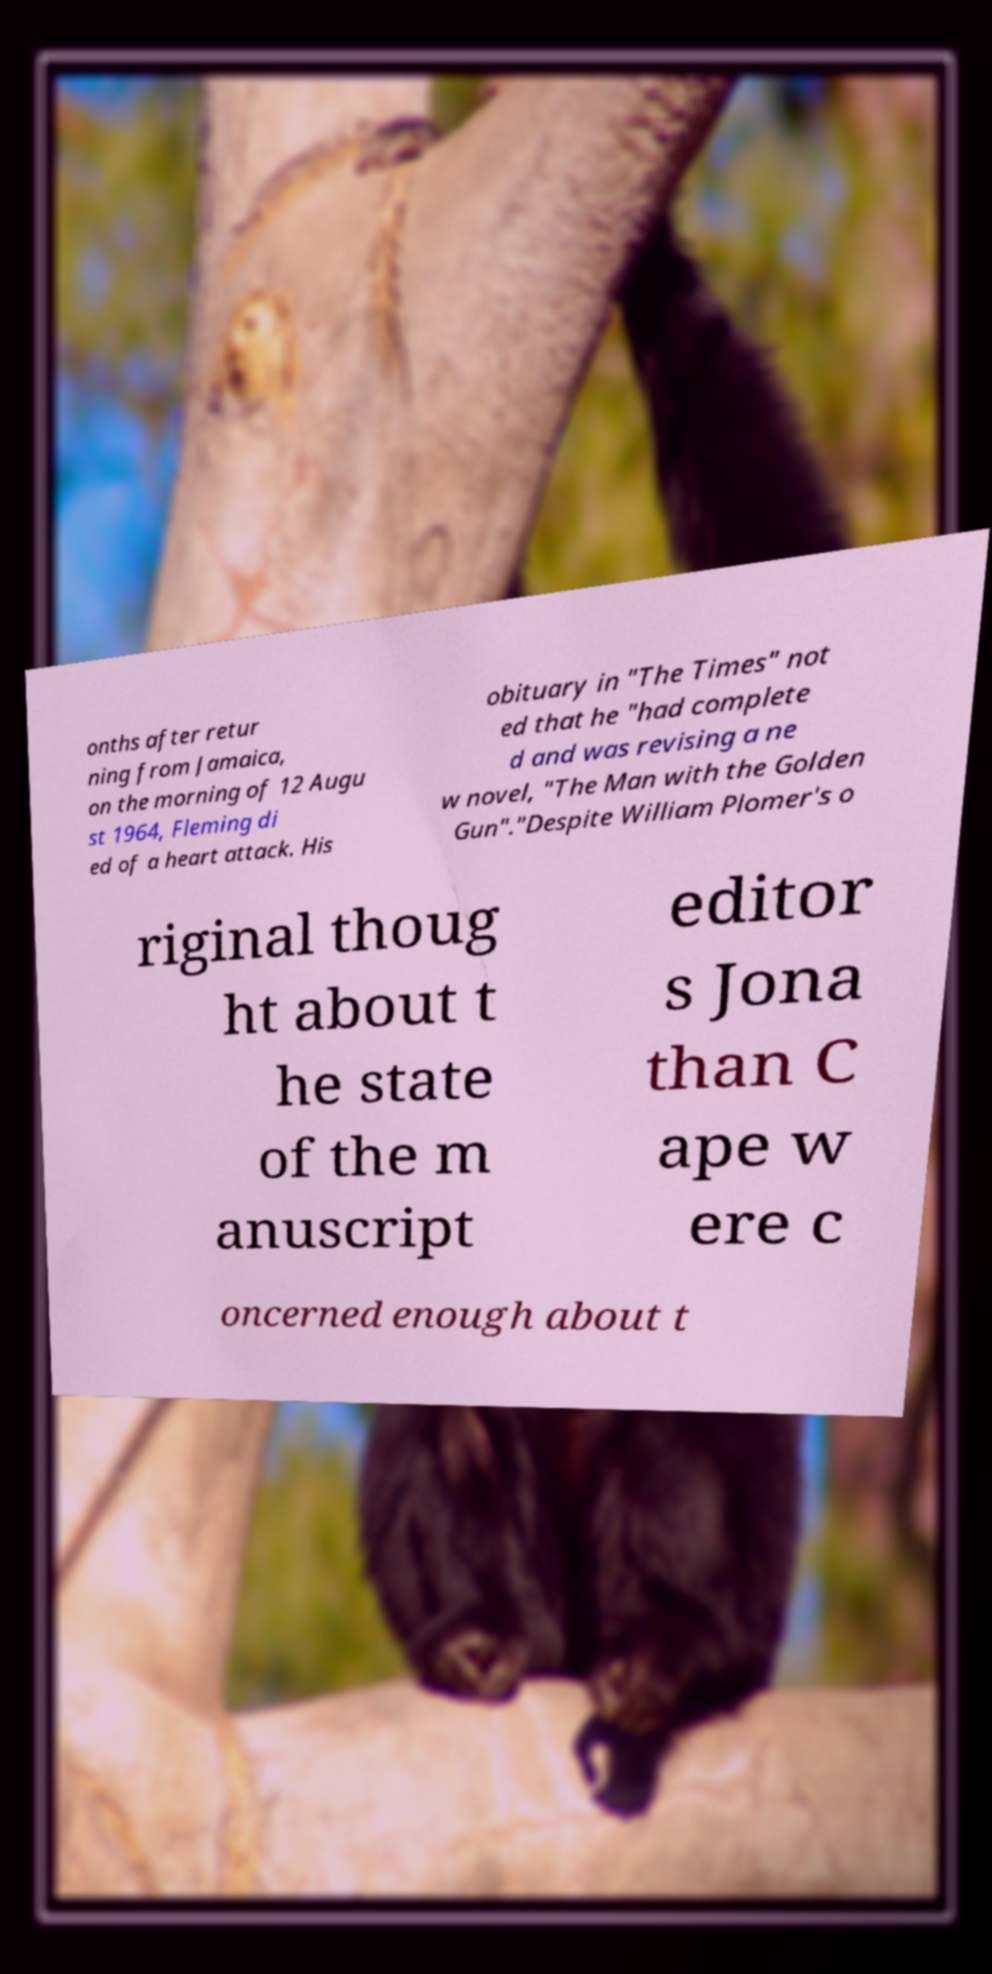Please read and relay the text visible in this image. What does it say? onths after retur ning from Jamaica, on the morning of 12 Augu st 1964, Fleming di ed of a heart attack. His obituary in "The Times" not ed that he "had complete d and was revising a ne w novel, "The Man with the Golden Gun"."Despite William Plomer's o riginal thoug ht about t he state of the m anuscript editor s Jona than C ape w ere c oncerned enough about t 